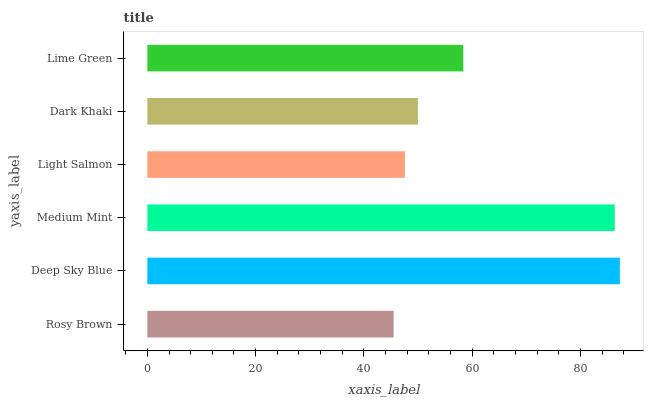Is Rosy Brown the minimum?
Answer yes or no. Yes. Is Deep Sky Blue the maximum?
Answer yes or no. Yes. Is Medium Mint the minimum?
Answer yes or no. No. Is Medium Mint the maximum?
Answer yes or no. No. Is Deep Sky Blue greater than Medium Mint?
Answer yes or no. Yes. Is Medium Mint less than Deep Sky Blue?
Answer yes or no. Yes. Is Medium Mint greater than Deep Sky Blue?
Answer yes or no. No. Is Deep Sky Blue less than Medium Mint?
Answer yes or no. No. Is Lime Green the high median?
Answer yes or no. Yes. Is Dark Khaki the low median?
Answer yes or no. Yes. Is Light Salmon the high median?
Answer yes or no. No. Is Medium Mint the low median?
Answer yes or no. No. 